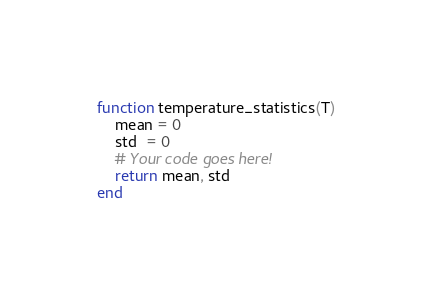<code> <loc_0><loc_0><loc_500><loc_500><_Julia_>function temperature_statistics(T)
    mean = 0
    std  = 0
    # Your code goes here!
    return mean, std
end
</code> 